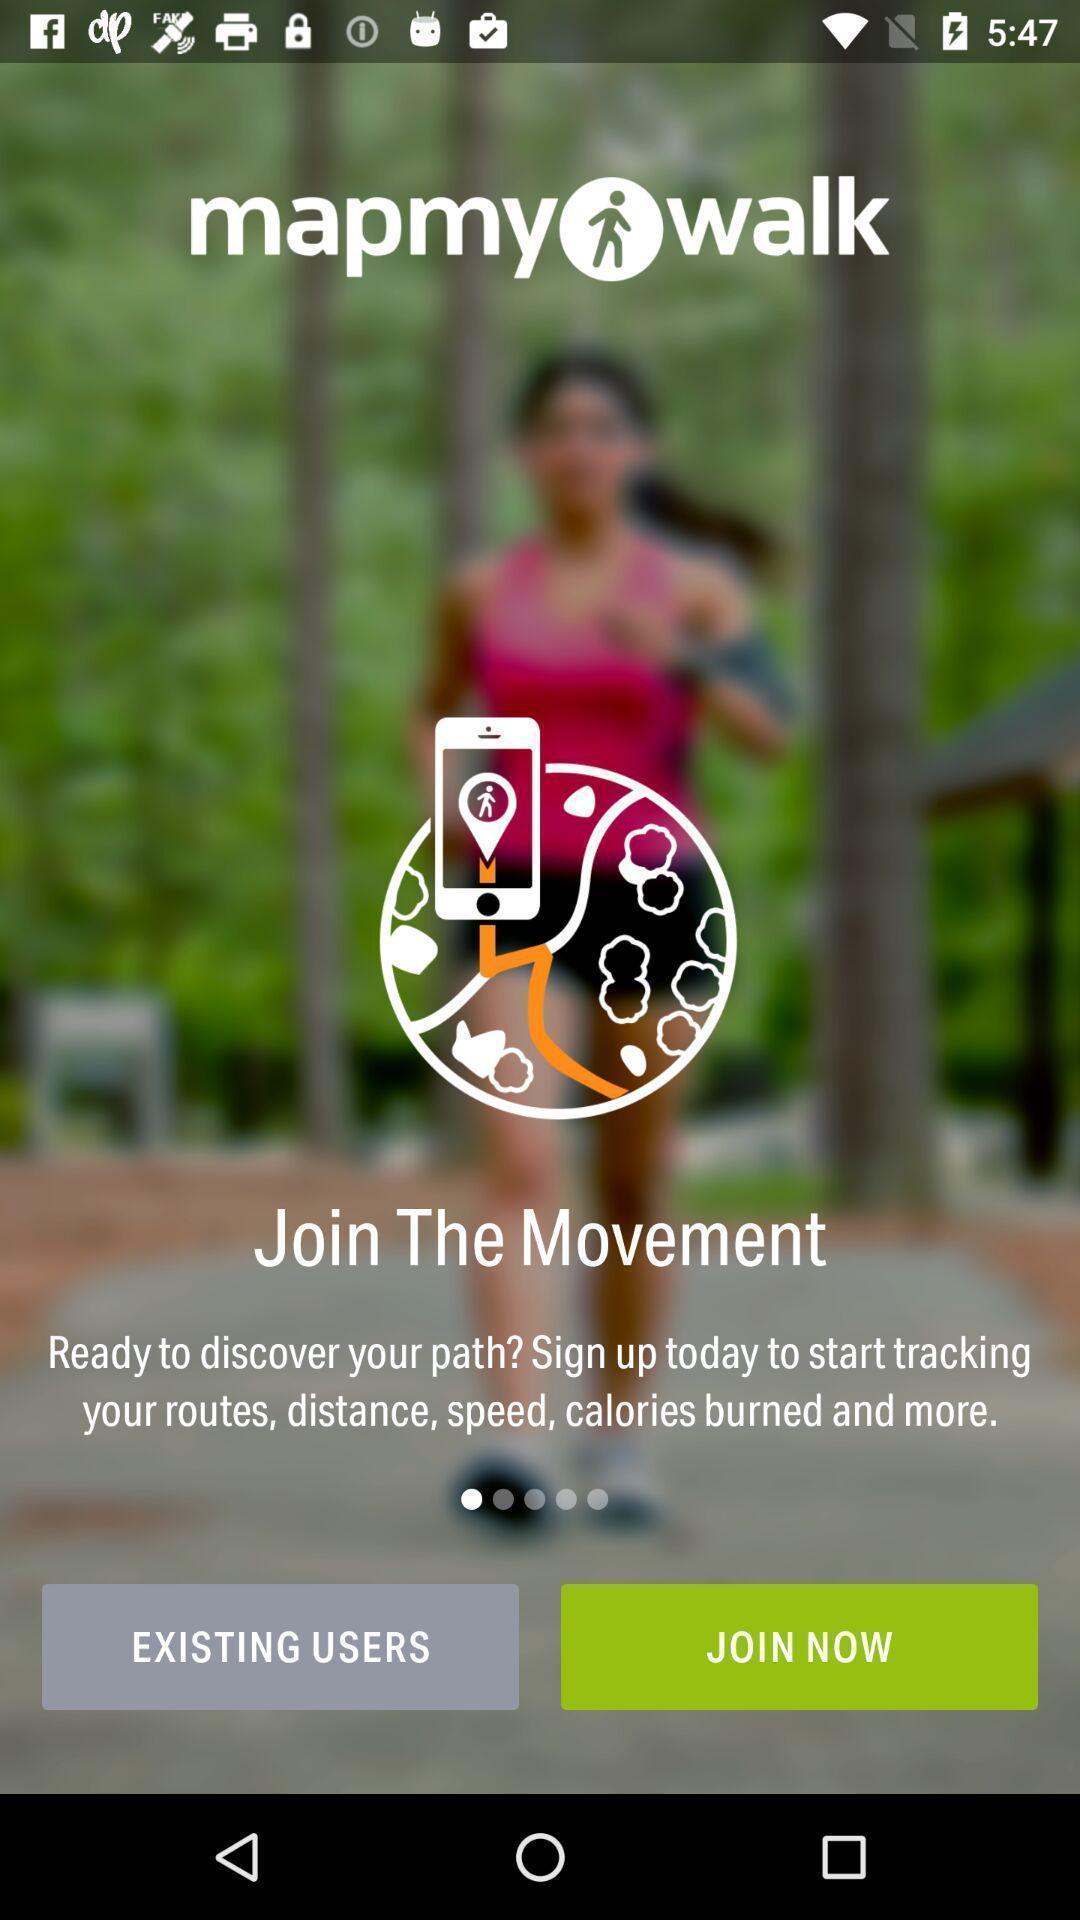Describe the key features of this screenshot. Welcome page to the application with information and options. 